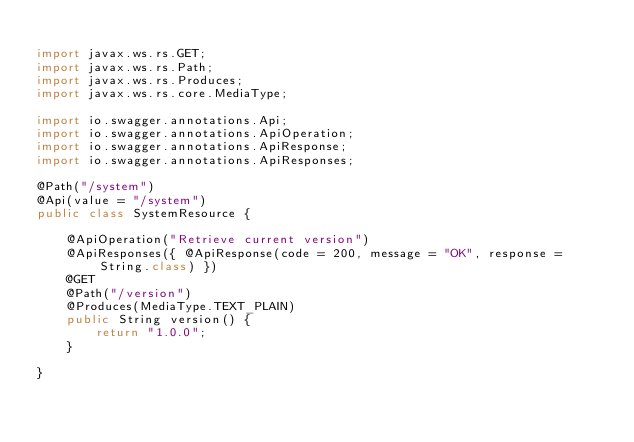Convert code to text. <code><loc_0><loc_0><loc_500><loc_500><_Java_>
import javax.ws.rs.GET;
import javax.ws.rs.Path;
import javax.ws.rs.Produces;
import javax.ws.rs.core.MediaType;

import io.swagger.annotations.Api;
import io.swagger.annotations.ApiOperation;
import io.swagger.annotations.ApiResponse;
import io.swagger.annotations.ApiResponses;

@Path("/system")
@Api(value = "/system")
public class SystemResource {

	@ApiOperation("Retrieve current version")
	@ApiResponses({ @ApiResponse(code = 200, message = "OK", response = String.class) })
	@GET
	@Path("/version")
	@Produces(MediaType.TEXT_PLAIN)
	public String version() {
		return "1.0.0";
	}

}
</code> 